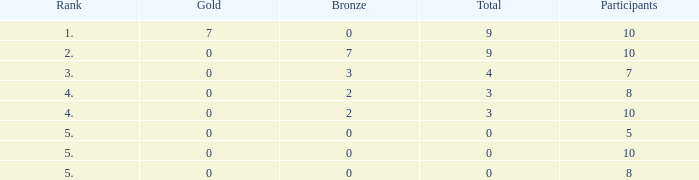What is listed as the highest Participants that also have a Rank of 5, and Silver that's smaller than 0? None. 